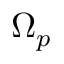<formula> <loc_0><loc_0><loc_500><loc_500>\Omega _ { p }</formula> 